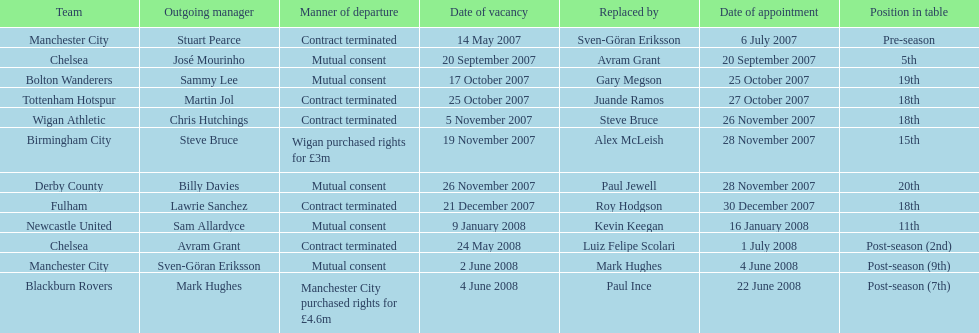How many teams had a manner of departure due to there contract being terminated? 5. 